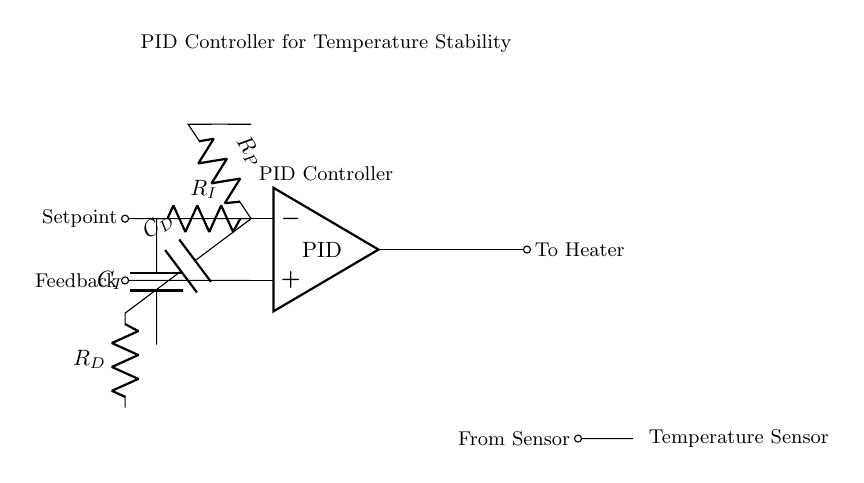What is the main function of the PID controller in this circuit? The PID controller regulates the temperature by adjusting the output to the heater based on the setpoint and feedback from the temperature sensor.
Answer: Regulate temperature What components are involved in the integral path? The integral path consists of a resistor labeled R_I and a capacitor labeled C_I. These components work together to integrate the error over time, contributing to the control action.
Answer: R_I, C_I What type of sensor is used in this circuit? A thermistor is used as the temperature sensor in this circuit, which provides feedback on the current temperature.
Answer: Thermistor What is the role of the output from the PID controller? The output from the PID controller is directed to the heater, which adjusts the temperature based on the feedback and desired setpoint.
Answer: To Heater How does the feedback mechanism influence the PID controller's function? The feedback from the thermistor informs the PID controller of the current temperature compared to the setpoint, allowing it to adjust the output to the heater for maintaining stability.
Answer: Adjust output Which path in the PID controller circuit directly provides a proportional response? The proportional response comes from the path through the resistor labeled R_P, which is directly connected to the negative input of the op-amp. This provides immediate correction based on the current error.
Answer: R_P 